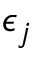<formula> <loc_0><loc_0><loc_500><loc_500>\epsilon _ { j }</formula> 